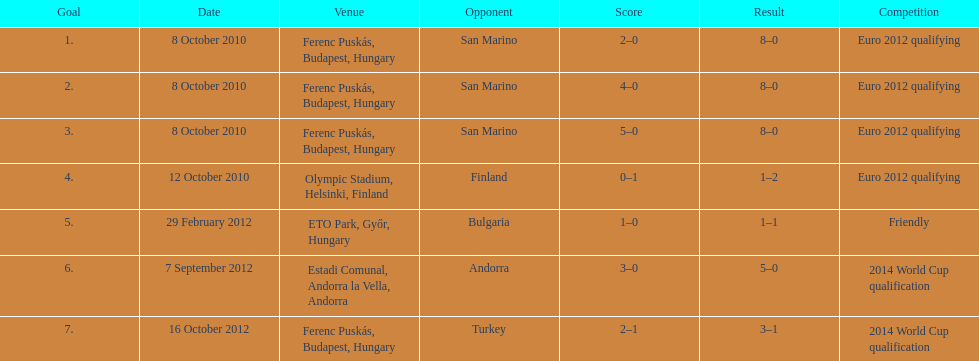Can you parse all the data within this table? {'header': ['Goal', 'Date', 'Venue', 'Opponent', 'Score', 'Result', 'Competition'], 'rows': [['1.', '8 October 2010', 'Ferenc Puskás, Budapest, Hungary', 'San Marino', '2–0', '8–0', 'Euro 2012 qualifying'], ['2.', '8 October 2010', 'Ferenc Puskás, Budapest, Hungary', 'San Marino', '4–0', '8–0', 'Euro 2012 qualifying'], ['3.', '8 October 2010', 'Ferenc Puskás, Budapest, Hungary', 'San Marino', '5–0', '8–0', 'Euro 2012 qualifying'], ['4.', '12 October 2010', 'Olympic Stadium, Helsinki, Finland', 'Finland', '0–1', '1–2', 'Euro 2012 qualifying'], ['5.', '29 February 2012', 'ETO Park, Győr, Hungary', 'Bulgaria', '1–0', '1–1', 'Friendly'], ['6.', '7 September 2012', 'Estadi Comunal, Andorra la Vella, Andorra', 'Andorra', '3–0', '5–0', '2014 World Cup qualification'], ['7.', '16 October 2012', 'Ferenc Puskás, Budapest, Hungary', 'Turkey', '2–1', '3–1', '2014 World Cup qualification']]} What is the total number of international goals ádám szalai has made? 7. 